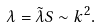<formula> <loc_0><loc_0><loc_500><loc_500>\lambda = \tilde { \lambda } S \sim k ^ { 2 } .</formula> 